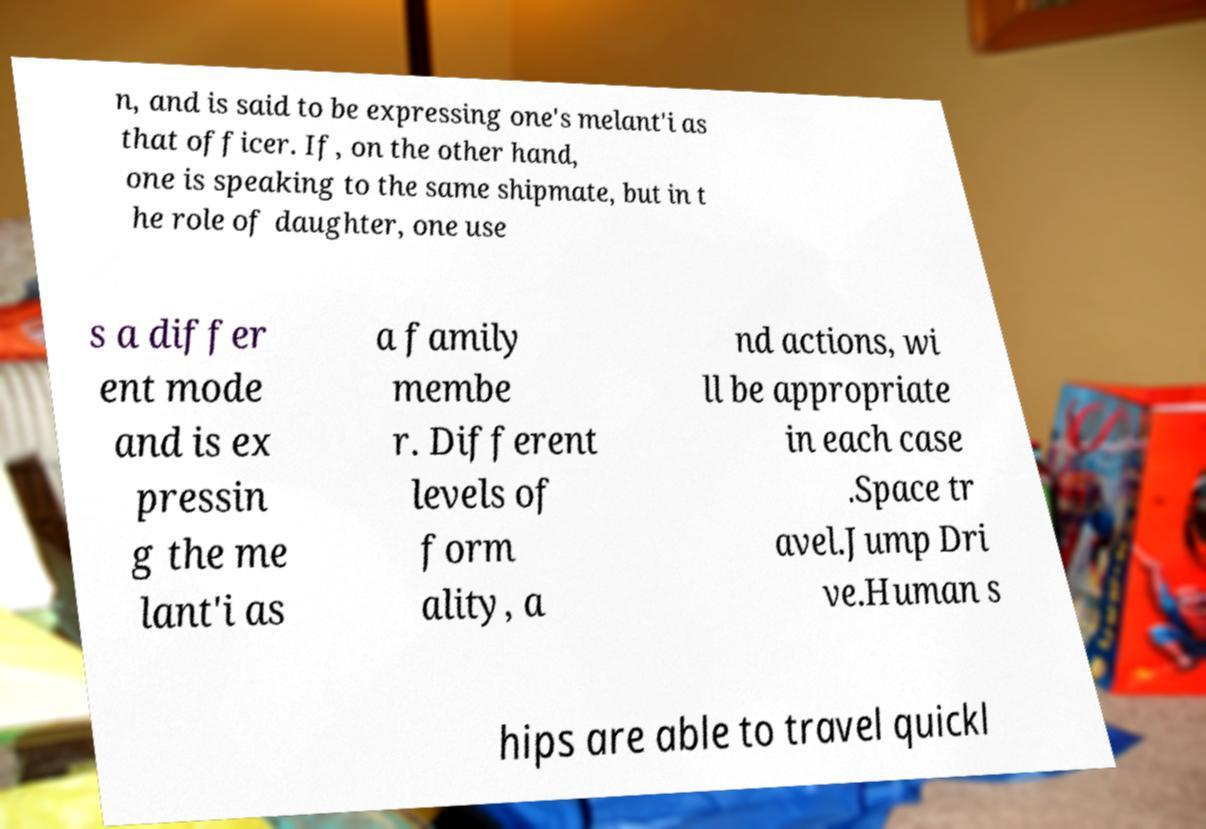Please identify and transcribe the text found in this image. n, and is said to be expressing one's melant'i as that officer. If, on the other hand, one is speaking to the same shipmate, but in t he role of daughter, one use s a differ ent mode and is ex pressin g the me lant'i as a family membe r. Different levels of form ality, a nd actions, wi ll be appropriate in each case .Space tr avel.Jump Dri ve.Human s hips are able to travel quickl 